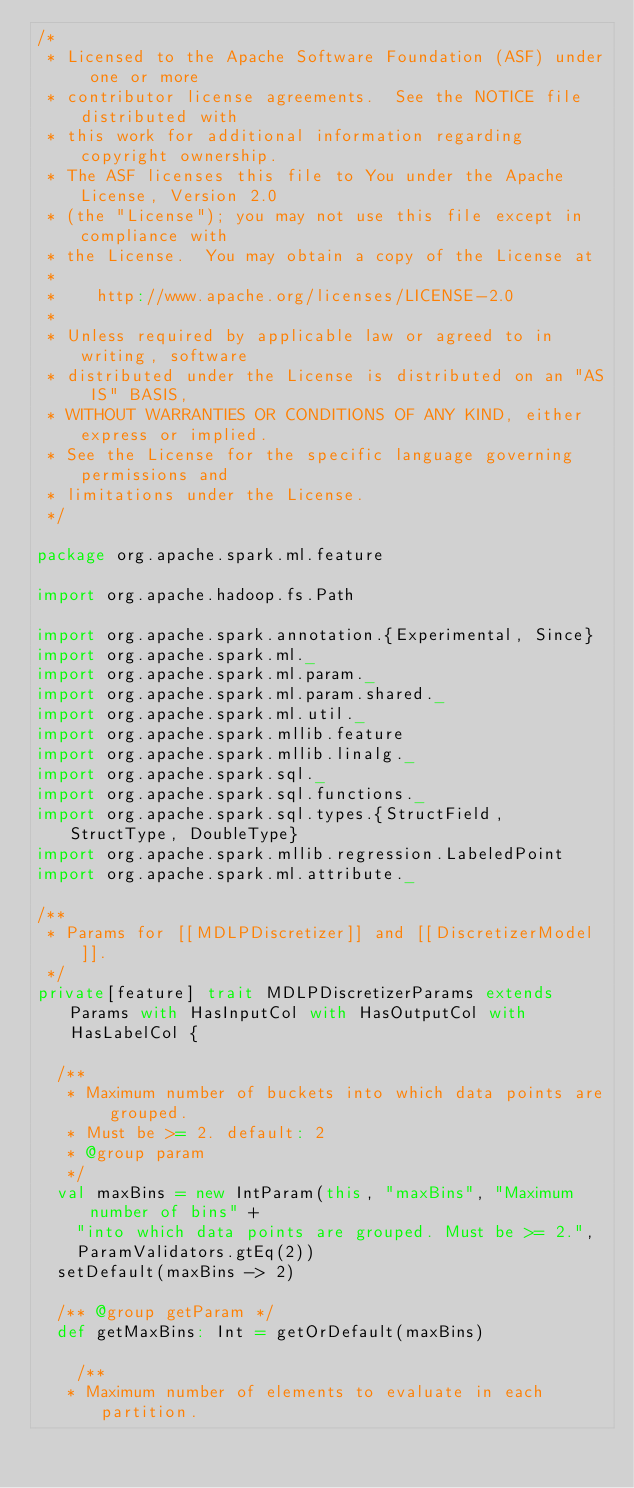Convert code to text. <code><loc_0><loc_0><loc_500><loc_500><_Scala_>/*
 * Licensed to the Apache Software Foundation (ASF) under one or more
 * contributor license agreements.  See the NOTICE file distributed with
 * this work for additional information regarding copyright ownership.
 * The ASF licenses this file to You under the Apache License, Version 2.0
 * (the "License"); you may not use this file except in compliance with
 * the License.  You may obtain a copy of the License at
 *
 *    http://www.apache.org/licenses/LICENSE-2.0
 *
 * Unless required by applicable law or agreed to in writing, software
 * distributed under the License is distributed on an "AS IS" BASIS,
 * WITHOUT WARRANTIES OR CONDITIONS OF ANY KIND, either express or implied.
 * See the License for the specific language governing permissions and
 * limitations under the License.
 */

package org.apache.spark.ml.feature

import org.apache.hadoop.fs.Path

import org.apache.spark.annotation.{Experimental, Since}
import org.apache.spark.ml._
import org.apache.spark.ml.param._
import org.apache.spark.ml.param.shared._
import org.apache.spark.ml.util._
import org.apache.spark.mllib.feature
import org.apache.spark.mllib.linalg._
import org.apache.spark.sql._
import org.apache.spark.sql.functions._
import org.apache.spark.sql.types.{StructField, StructType, DoubleType}
import org.apache.spark.mllib.regression.LabeledPoint
import org.apache.spark.ml.attribute._

/**
 * Params for [[MDLPDiscretizer]] and [[DiscretizerModel]].
 */
private[feature] trait MDLPDiscretizerParams extends Params with HasInputCol with HasOutputCol with HasLabelCol {

  /**
   * Maximum number of buckets into which data points are grouped. 
   * Must be >= 2. default: 2
   * @group param
   */
  val maxBins = new IntParam(this, "maxBins", "Maximum number of bins" +
    "into which data points are grouped. Must be >= 2.",
    ParamValidators.gtEq(2))
  setDefault(maxBins -> 2)

  /** @group getParam */
  def getMaxBins: Int = getOrDefault(maxBins)
  
    /**
   * Maximum number of elements to evaluate in each partition. </code> 